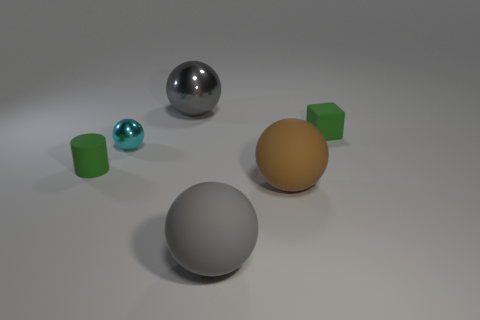Subtract 1 balls. How many balls are left? 3 Add 3 big metallic spheres. How many objects exist? 9 Subtract all cylinders. How many objects are left? 5 Add 2 cyan metallic spheres. How many cyan metallic spheres are left? 3 Add 6 metal spheres. How many metal spheres exist? 8 Subtract 0 purple cylinders. How many objects are left? 6 Subtract all cyan spheres. Subtract all large gray matte balls. How many objects are left? 4 